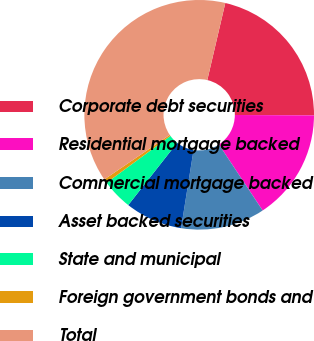Convert chart to OTSL. <chart><loc_0><loc_0><loc_500><loc_500><pie_chart><fcel>Corporate debt securities<fcel>Residential mortgage backed<fcel>Commercial mortgage backed<fcel>Asset backed securities<fcel>State and municipal<fcel>Foreign government bonds and<fcel>Total<nl><fcel>21.43%<fcel>15.6%<fcel>11.84%<fcel>8.08%<fcel>4.32%<fcel>0.56%<fcel>38.17%<nl></chart> 